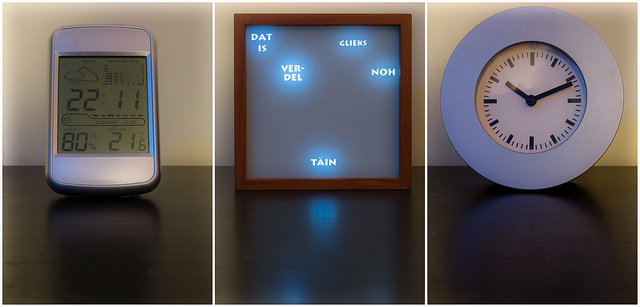Identify and read out the text in this image. DAT TAIN NOH 6 21 80 22 DEL VER- 